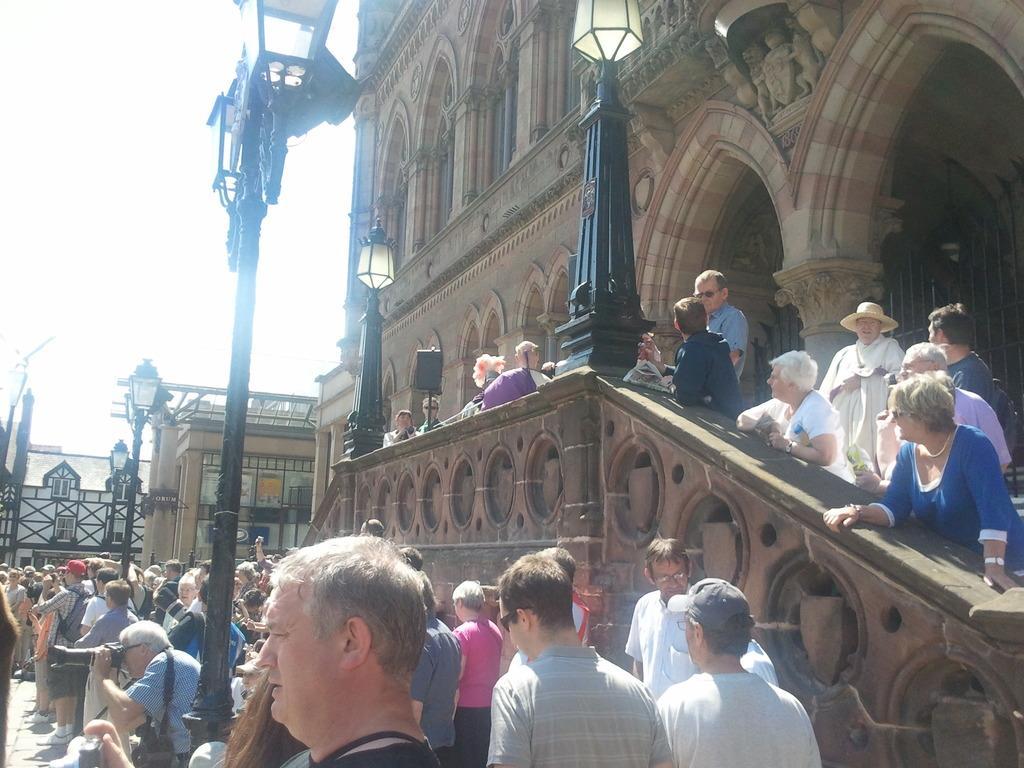How would you summarize this image in a sentence or two? In this picture we can see there are groups of people and there are poles with lights. On the right side of the people there are buildings. Behind the buildings there is the sky. 